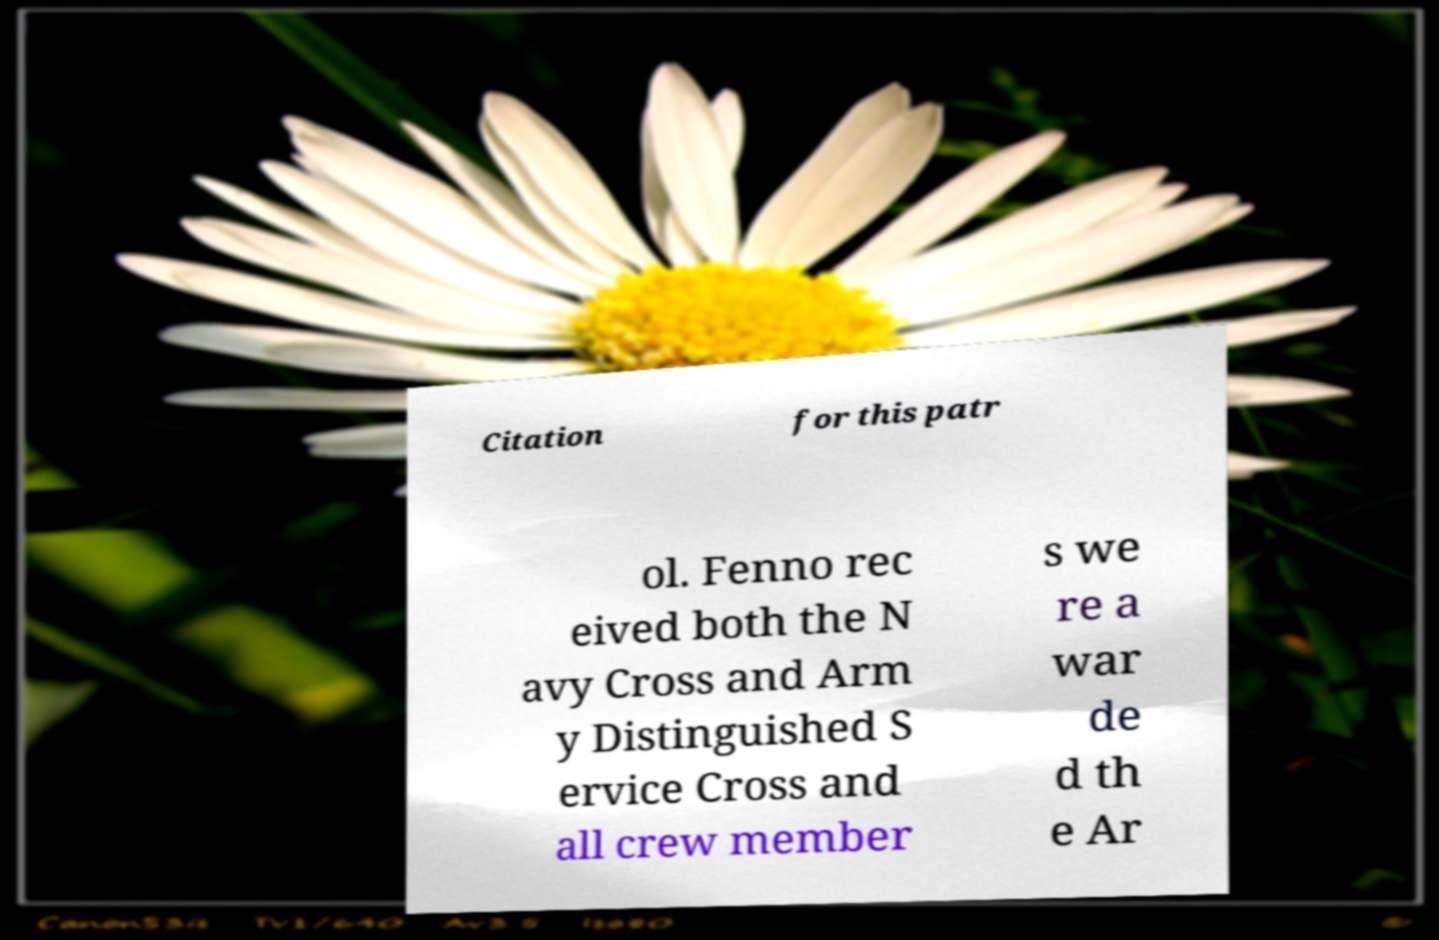Could you extract and type out the text from this image? Citation for this patr ol. Fenno rec eived both the N avy Cross and Arm y Distinguished S ervice Cross and all crew member s we re a war de d th e Ar 